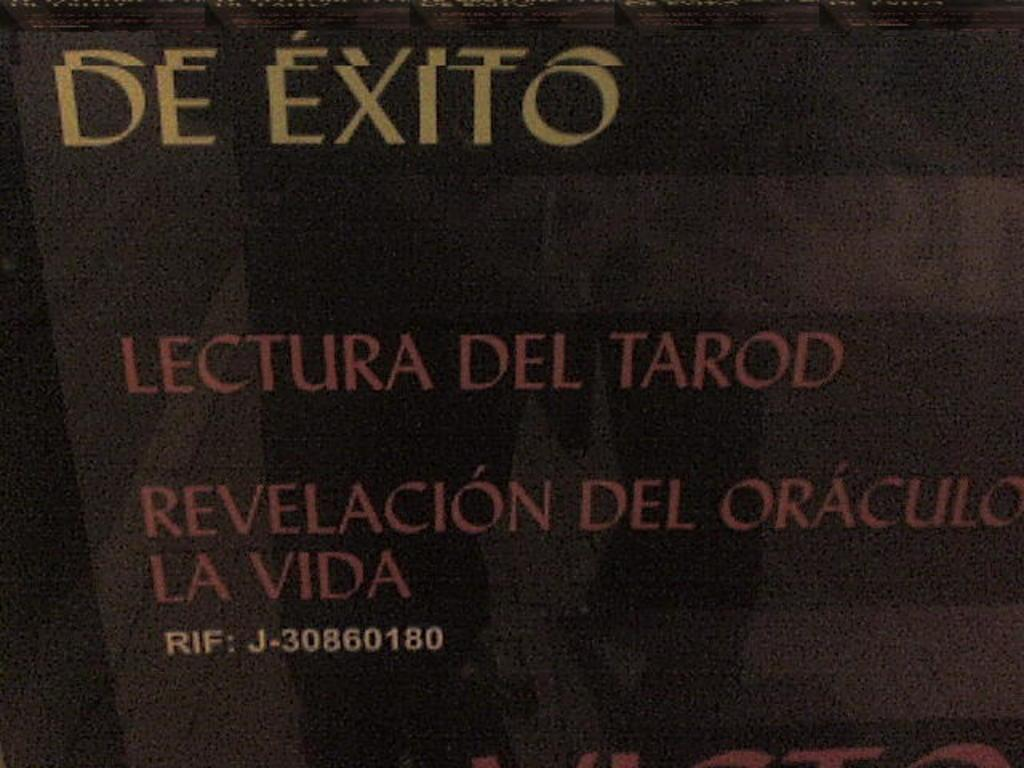<image>
Write a terse but informative summary of the picture. A poster that says De Exito Lectura Del Tarod Revelacion Del Oraculo La Vida. 